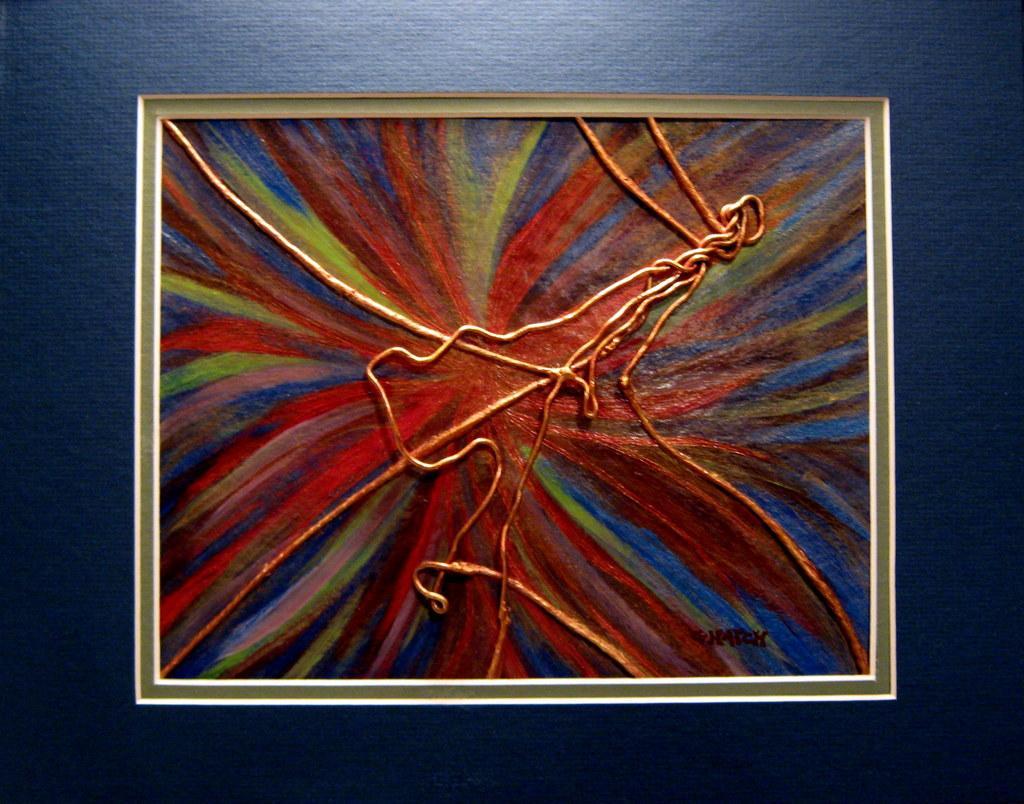Could you give a brief overview of what you see in this image? In this image we can see photo frame with painting. And the photo frame is on the wall. 